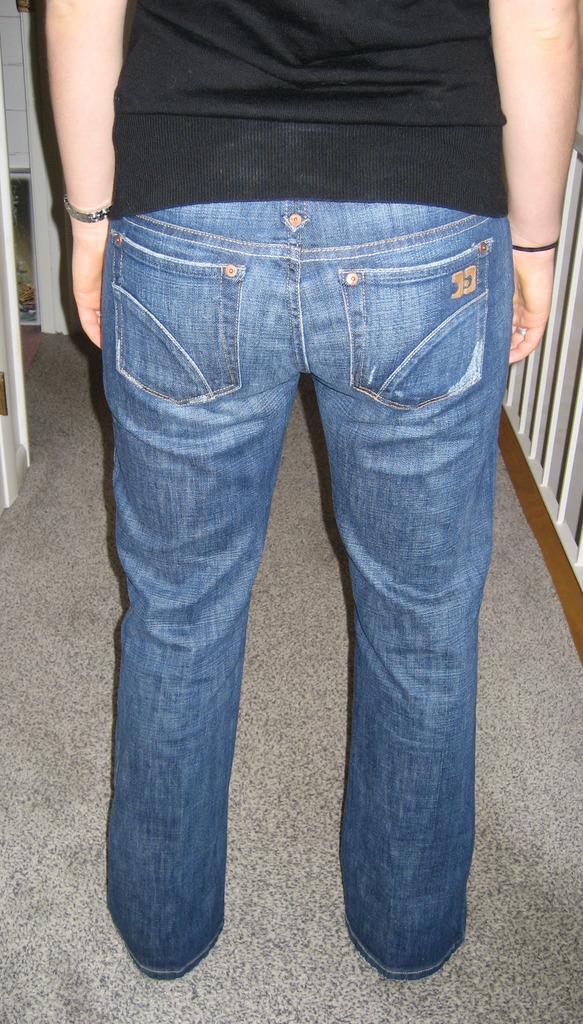What is the primary subject in the image? There is a person standing in the image. What is the person's position in relation to the ground? The person is standing on the floor. Can you describe the background of the image? There are objects visible in the background of the image. How many icicles are hanging from the person's arm in the image? There are no icicles present in the image, and the person's arm is not mentioned in the provided facts. 